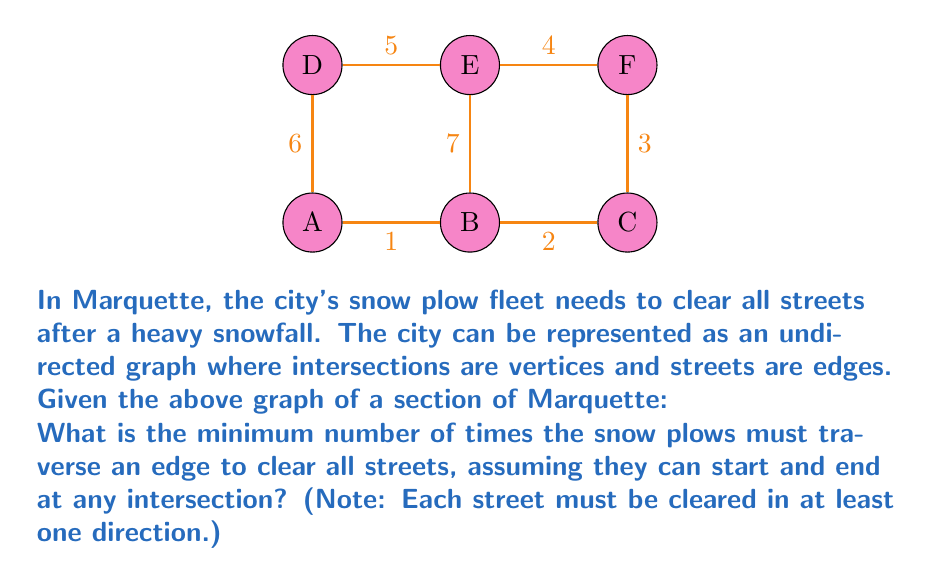Solve this math problem. To solve this problem, we need to use the concept of Euler tours in graph theory. The most efficient route for snow plows is equivalent to finding an Euler tour or Euler path in the graph.

Steps to solve:
1) First, we need to check if the graph has an Euler tour or path.
   - An Euler tour exists if all vertices have even degree.
   - An Euler path exists if exactly two vertices have odd degree.

2) Count the degree of each vertex:
   A: 3, B: 4, C: 2, D: 3, E: 4, F: 2

3) We have four vertices with odd degree (A, C, D, F), so there is no Euler tour or path.

4) In this case, we need to find the minimum number of edge traversals to cover all edges at least once. This is known as the Chinese Postman Problem.

5) The solution is to add the minimum number of edges to make all vertices even degree. We need to add two edges:
   - One connecting A to D
   - One connecting C to F

6) After adding these imaginary edges, we have an Euler tour.

7) The number of edge traversals will be:
   $$\text{Original edges} + \text{Added edges} = 7 + 2 = 9$$

Therefore, the snow plows must traverse 9 edges in total to clear all streets efficiently.
Answer: 9 edge traversals 